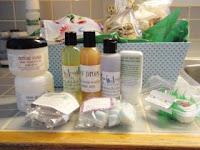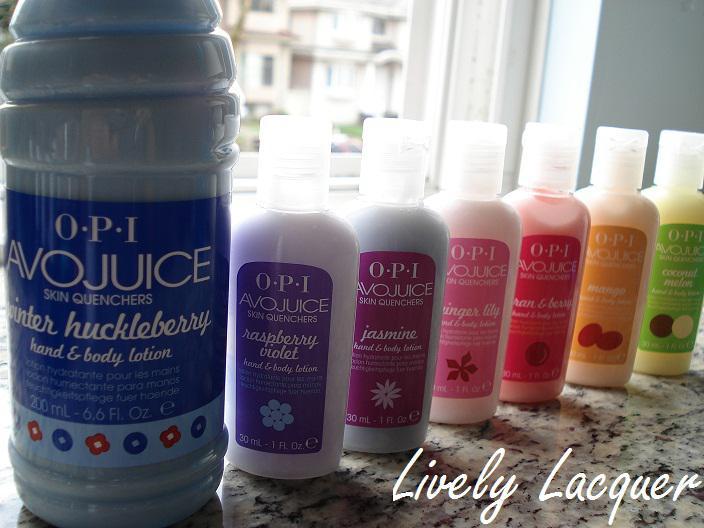The first image is the image on the left, the second image is the image on the right. For the images shown, is this caption "There are five lotions/fragrances in total." true? Answer yes or no. No. The first image is the image on the left, the second image is the image on the right. Analyze the images presented: Is the assertion "The images contain no more than three beauty products." valid? Answer yes or no. No. 